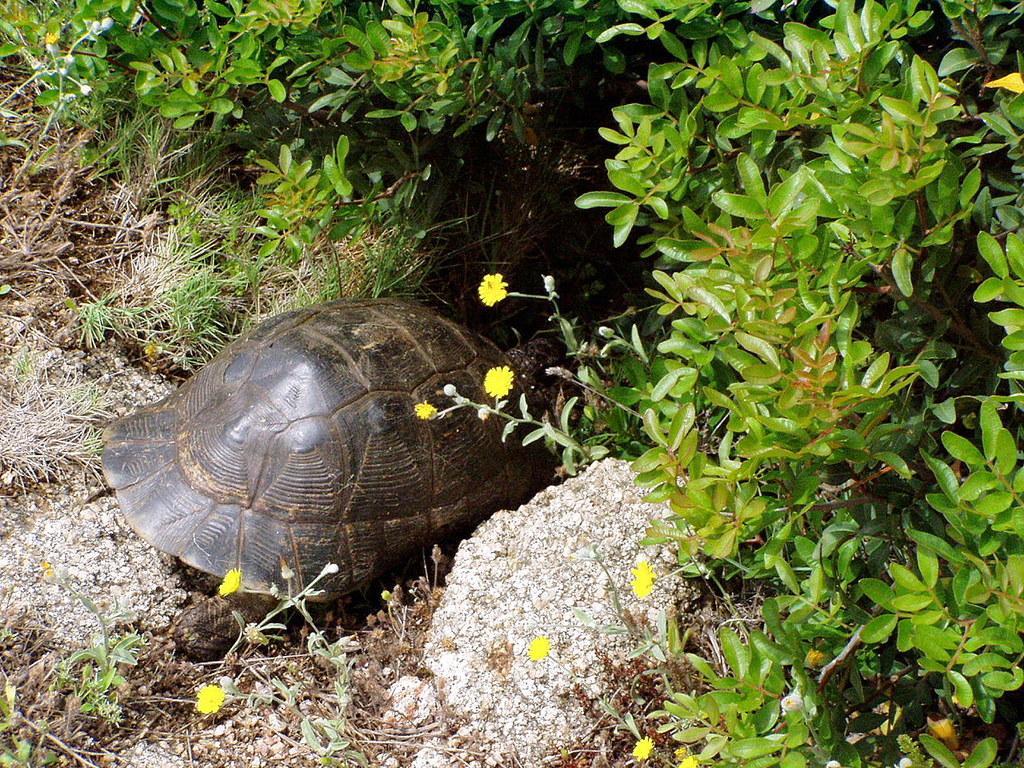Please provide a concise description of this image. On the right there are plants, flowers and stone. In the center of the picture there is a tortoise. On the left there are shrubs. At the bottom there are plants, flowers and soil. At the top there are plants. 